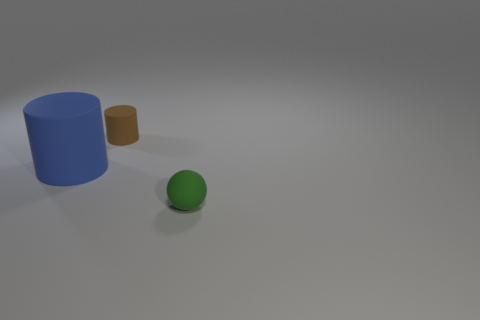Is there any other thing that has the same color as the big cylinder?
Your answer should be compact. No. There is a rubber cylinder that is in front of the small rubber thing behind the green rubber object; what is its color?
Ensure brevity in your answer.  Blue. Are there fewer spheres that are to the right of the green object than small brown rubber things to the right of the big rubber object?
Your answer should be very brief. Yes. How many objects are either rubber cylinders that are right of the blue thing or yellow spheres?
Provide a succinct answer. 1. There is a thing in front of the blue cylinder; is it the same size as the small matte cylinder?
Provide a succinct answer. Yes. Is the number of green matte objects that are left of the small green matte thing less than the number of yellow matte balls?
Make the answer very short. No. What number of small objects are blue rubber cylinders or blue matte blocks?
Keep it short and to the point. 0. How many things are objects behind the big blue cylinder or tiny things that are behind the green object?
Keep it short and to the point. 1. Is the number of small cyan matte spheres less than the number of big things?
Your response must be concise. Yes. What is the shape of the rubber object that is the same size as the sphere?
Ensure brevity in your answer.  Cylinder. 